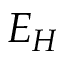<formula> <loc_0><loc_0><loc_500><loc_500>E _ { H }</formula> 